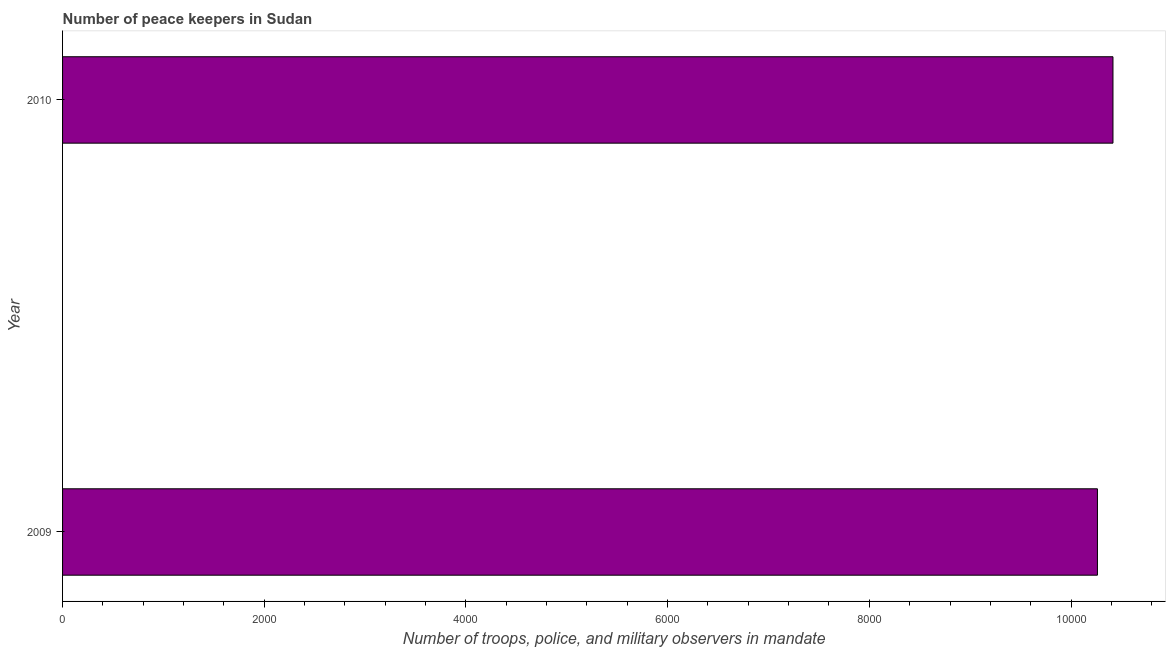Does the graph contain grids?
Your answer should be very brief. No. What is the title of the graph?
Your answer should be very brief. Number of peace keepers in Sudan. What is the label or title of the X-axis?
Your answer should be compact. Number of troops, police, and military observers in mandate. What is the number of peace keepers in 2010?
Offer a very short reply. 1.04e+04. Across all years, what is the maximum number of peace keepers?
Ensure brevity in your answer.  1.04e+04. Across all years, what is the minimum number of peace keepers?
Ensure brevity in your answer.  1.03e+04. In which year was the number of peace keepers maximum?
Give a very brief answer. 2010. What is the sum of the number of peace keepers?
Your answer should be compact. 2.07e+04. What is the difference between the number of peace keepers in 2009 and 2010?
Keep it short and to the point. -154. What is the average number of peace keepers per year?
Your answer should be very brief. 1.03e+04. What is the median number of peace keepers?
Ensure brevity in your answer.  1.03e+04. What is the ratio of the number of peace keepers in 2009 to that in 2010?
Provide a succinct answer. 0.98. Is the number of peace keepers in 2009 less than that in 2010?
Offer a terse response. Yes. How many bars are there?
Make the answer very short. 2. What is the difference between two consecutive major ticks on the X-axis?
Provide a short and direct response. 2000. Are the values on the major ticks of X-axis written in scientific E-notation?
Your response must be concise. No. What is the Number of troops, police, and military observers in mandate of 2009?
Offer a very short reply. 1.03e+04. What is the Number of troops, police, and military observers in mandate of 2010?
Make the answer very short. 1.04e+04. What is the difference between the Number of troops, police, and military observers in mandate in 2009 and 2010?
Make the answer very short. -154. What is the ratio of the Number of troops, police, and military observers in mandate in 2009 to that in 2010?
Give a very brief answer. 0.98. 